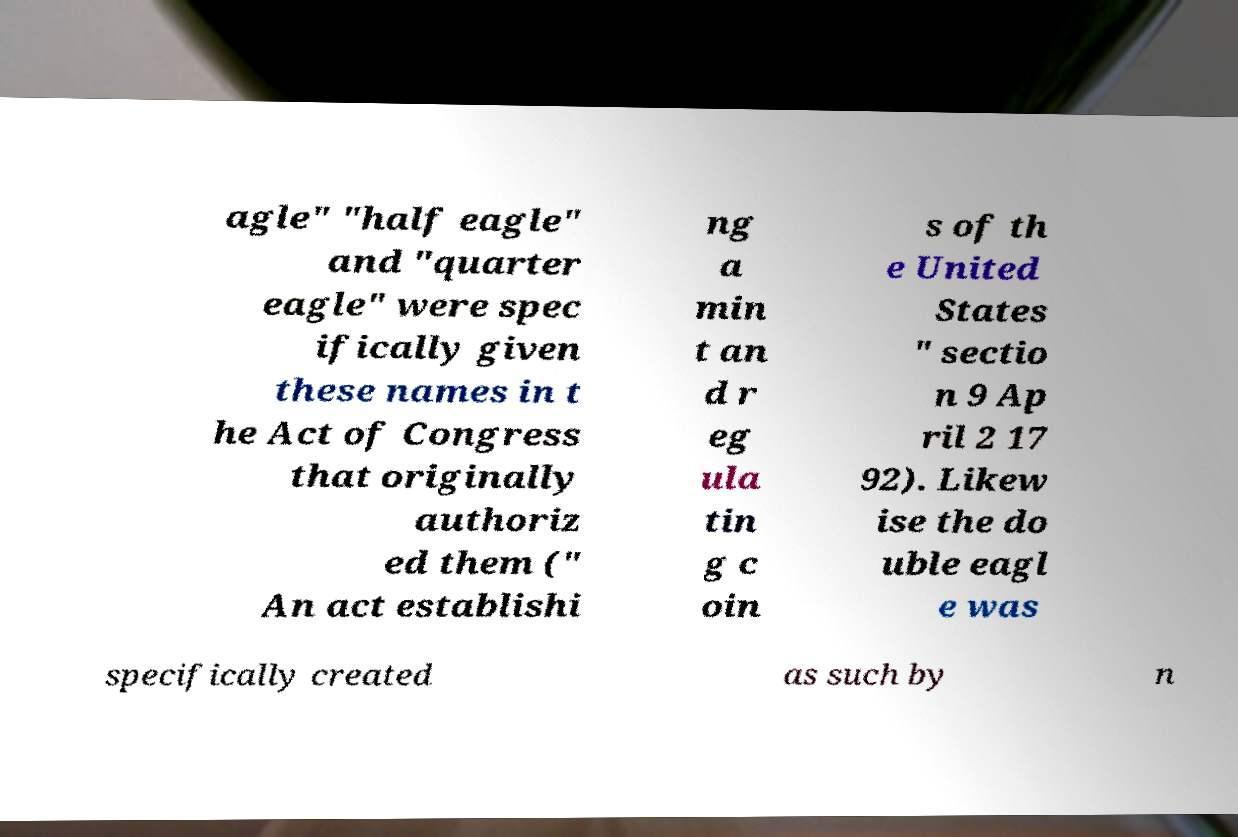Please read and relay the text visible in this image. What does it say? agle" "half eagle" and "quarter eagle" were spec ifically given these names in t he Act of Congress that originally authoriz ed them (" An act establishi ng a min t an d r eg ula tin g c oin s of th e United States " sectio n 9 Ap ril 2 17 92). Likew ise the do uble eagl e was specifically created as such by n 